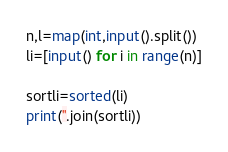<code> <loc_0><loc_0><loc_500><loc_500><_Python_>n,l=map(int,input().split())
li=[input() for i in range(n)]

sortli=sorted(li)
print(''.join(sortli))</code> 